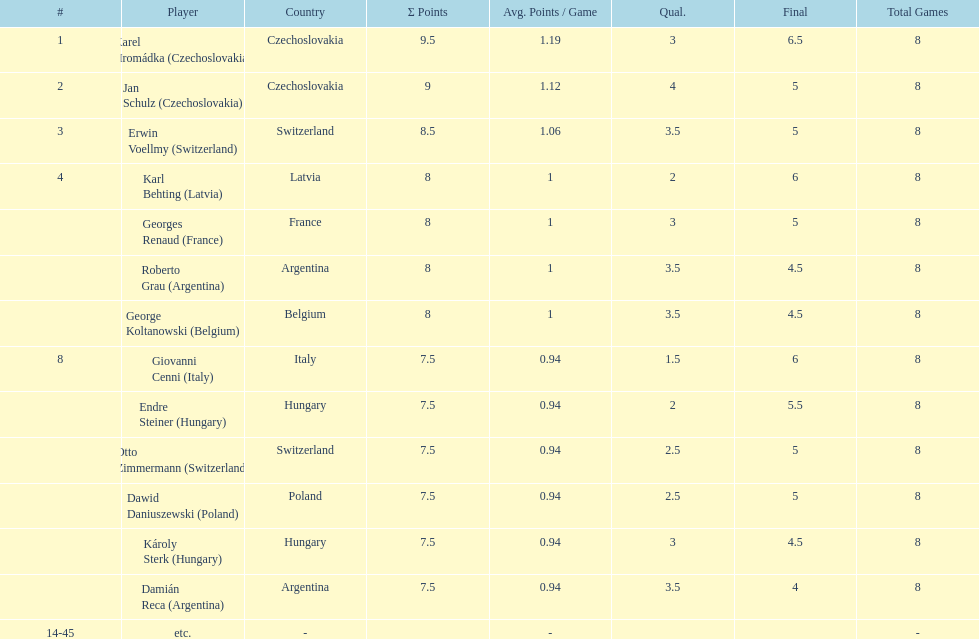Who was the top scorer from switzerland? Erwin Voellmy. Can you parse all the data within this table? {'header': ['#', 'Player', 'Country', 'Σ Points', 'Avg. Points / Game', 'Qual.', 'Final', 'Total Games'], 'rows': [['1', 'Karel Hromádka\xa0(Czechoslovakia)', 'Czechoslovakia', '9.5', '1.19', '3', '6.5', '8'], ['2', 'Jan Schulz\xa0(Czechoslovakia)', 'Czechoslovakia', '9', '1.12', '4', '5', '8'], ['3', 'Erwin Voellmy\xa0(Switzerland)', 'Switzerland', '8.5', '1.06', '3.5', '5', '8'], ['4', 'Karl Behting\xa0(Latvia)', 'Latvia', '8', '1', '2', '6', '8'], ['', 'Georges Renaud\xa0(France)', 'France', '8', '1', '3', '5', '8'], ['', 'Roberto Grau\xa0(Argentina)', 'Argentina', '8', '1', '3.5', '4.5', '8'], ['', 'George Koltanowski\xa0(Belgium)', 'Belgium', '8', '1', '3.5', '4.5', '8'], ['8', 'Giovanni Cenni\xa0(Italy)', 'Italy', '7.5', '0.94', '1.5', '6', '8'], ['', 'Endre Steiner\xa0(Hungary)', 'Hungary', '7.5', '0.94', '2', '5.5', '8'], ['', 'Otto Zimmermann\xa0(Switzerland)', 'Switzerland', '7.5', '0.94', '2.5', '5', '8'], ['', 'Dawid Daniuszewski\xa0(Poland)', 'Poland', '7.5', '0.94', '2.5', '5', '8'], ['', 'Károly Sterk\xa0(Hungary)', 'Hungary', '7.5', '0.94', '3', '4.5', '8'], ['', 'Damián Reca\xa0(Argentina)', 'Argentina', '7.5', '0.94', '3.5', '4', '8'], ['14-45', 'etc.', '-', '', '-', '', '', '-']]} 